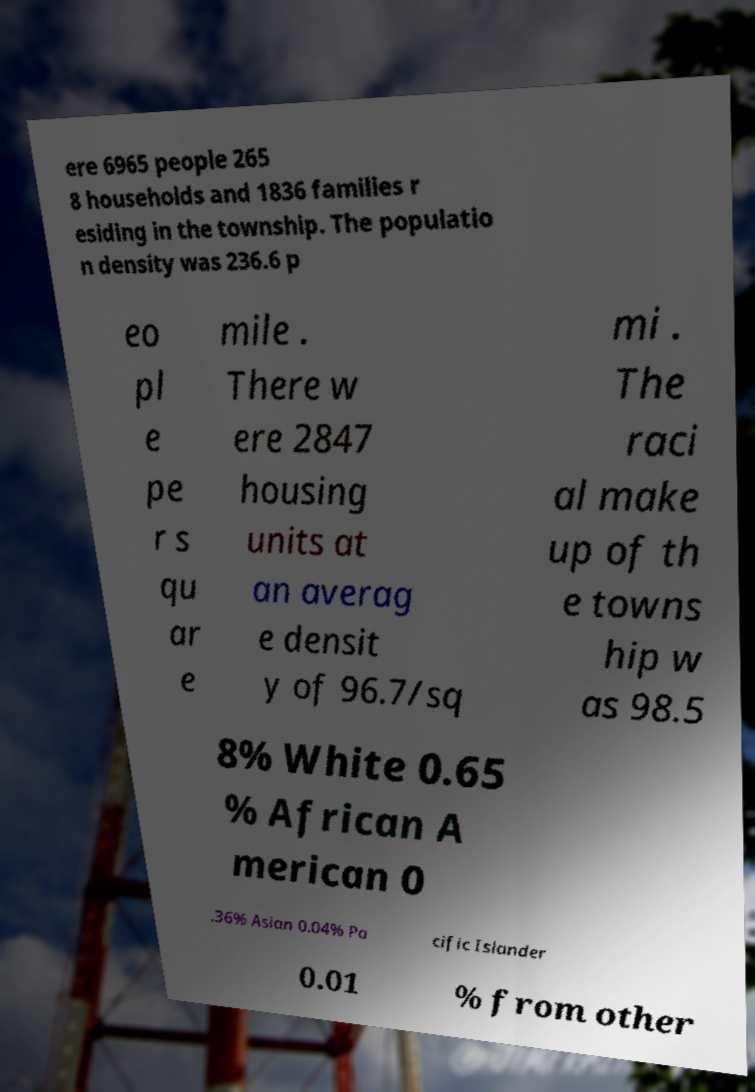I need the written content from this picture converted into text. Can you do that? ere 6965 people 265 8 households and 1836 families r esiding in the township. The populatio n density was 236.6 p eo pl e pe r s qu ar e mile . There w ere 2847 housing units at an averag e densit y of 96.7/sq mi . The raci al make up of th e towns hip w as 98.5 8% White 0.65 % African A merican 0 .36% Asian 0.04% Pa cific Islander 0.01 % from other 